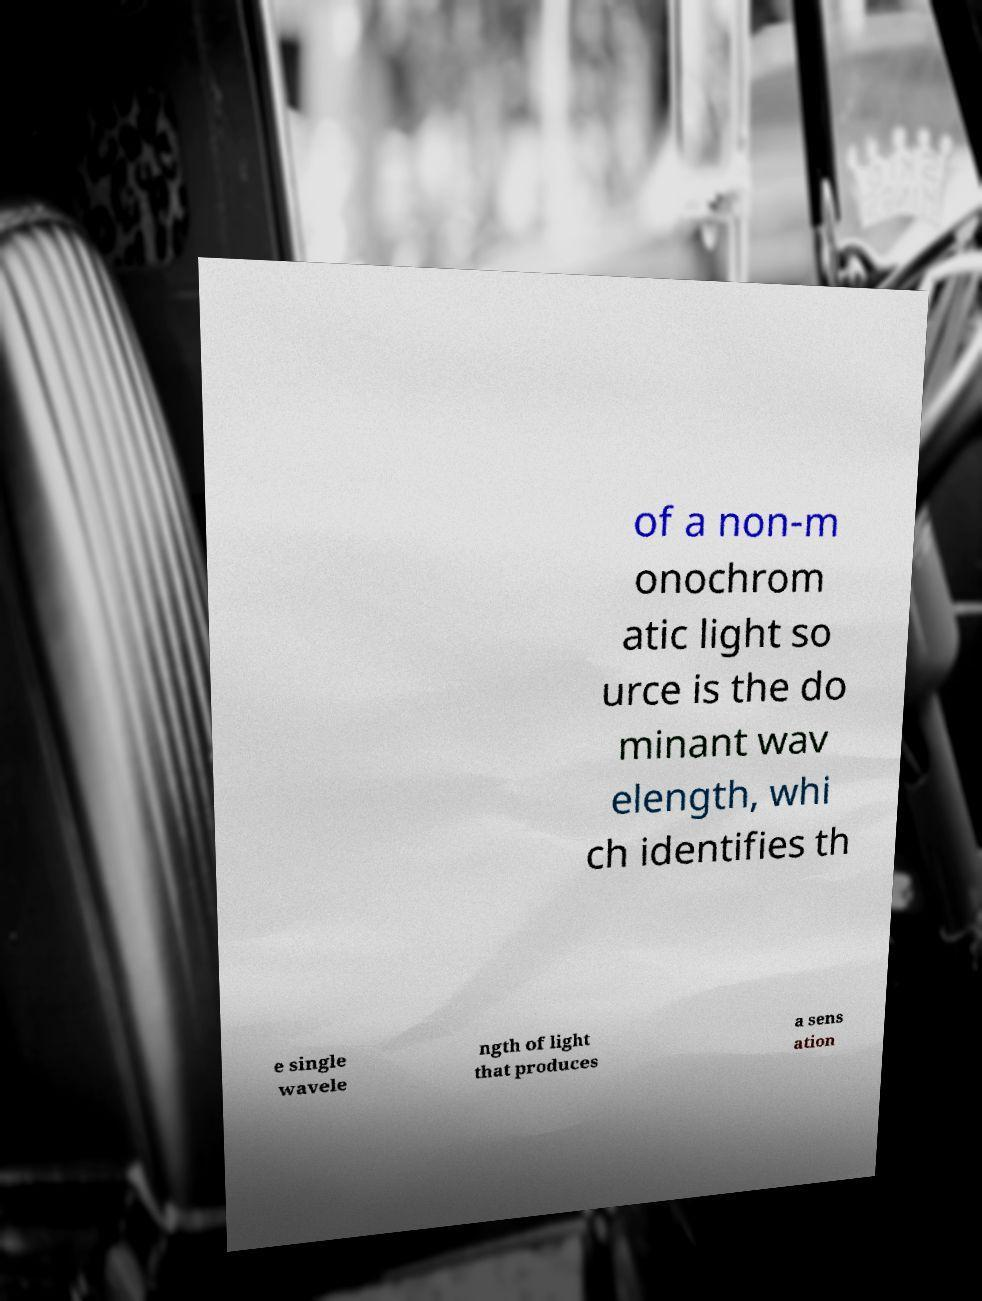Please read and relay the text visible in this image. What does it say? of a non-m onochrom atic light so urce is the do minant wav elength, whi ch identifies th e single wavele ngth of light that produces a sens ation 